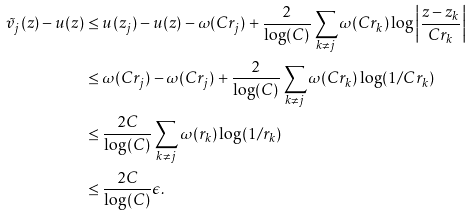<formula> <loc_0><loc_0><loc_500><loc_500>\tilde { v } _ { j } ( z ) - u ( z ) & \leq u ( z _ { j } ) - u ( z ) - \omega ( C r _ { j } ) + \frac { 2 } { \log ( C ) } \sum _ { k \neq j } \omega ( C r _ { k } ) \log \left | \frac { z - z _ { k } } { C r _ { k } } \right | \\ & \leq \omega ( C r _ { j } ) - \omega ( C r _ { j } ) + \frac { 2 } { \log ( C ) } \sum _ { k \neq j } \omega ( C r _ { k } ) \log ( 1 / C r _ { k } ) \\ & \leq \frac { 2 C } { \log ( C ) } \sum _ { k \neq j } \omega ( r _ { k } ) \log ( 1 / r _ { k } ) \\ & \leq \frac { 2 C } { \log ( C ) } \epsilon .</formula> 